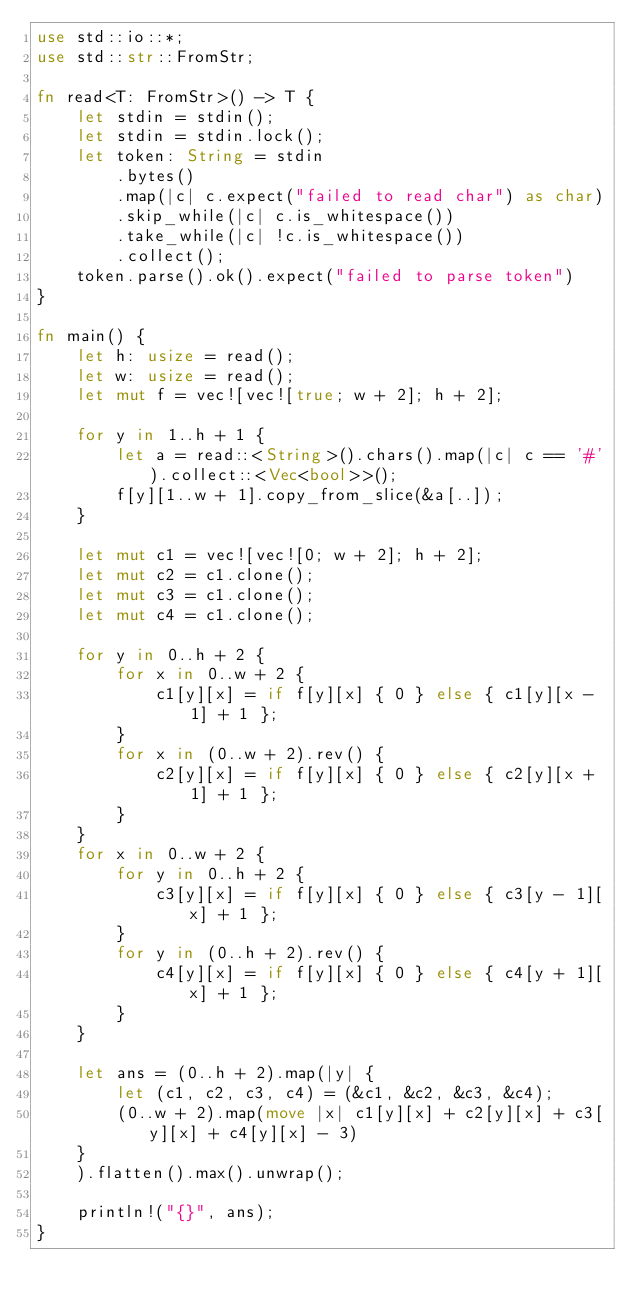Convert code to text. <code><loc_0><loc_0><loc_500><loc_500><_Rust_>use std::io::*;
use std::str::FromStr;

fn read<T: FromStr>() -> T {
    let stdin = stdin();
    let stdin = stdin.lock();
    let token: String = stdin
        .bytes()
        .map(|c| c.expect("failed to read char") as char)
        .skip_while(|c| c.is_whitespace())
        .take_while(|c| !c.is_whitespace())
        .collect();
    token.parse().ok().expect("failed to parse token")
}

fn main() {
    let h: usize = read();
    let w: usize = read();
    let mut f = vec![vec![true; w + 2]; h + 2];

    for y in 1..h + 1 {
        let a = read::<String>().chars().map(|c| c == '#').collect::<Vec<bool>>();
        f[y][1..w + 1].copy_from_slice(&a[..]);
    }

    let mut c1 = vec![vec![0; w + 2]; h + 2];
    let mut c2 = c1.clone();
    let mut c3 = c1.clone();
    let mut c4 = c1.clone();

    for y in 0..h + 2 {
        for x in 0..w + 2 {
            c1[y][x] = if f[y][x] { 0 } else { c1[y][x - 1] + 1 };
        }
        for x in (0..w + 2).rev() {
            c2[y][x] = if f[y][x] { 0 } else { c2[y][x + 1] + 1 };
        }
    }
    for x in 0..w + 2 {
        for y in 0..h + 2 {
            c3[y][x] = if f[y][x] { 0 } else { c3[y - 1][x] + 1 };
        }
        for y in (0..h + 2).rev() {
            c4[y][x] = if f[y][x] { 0 } else { c4[y + 1][x] + 1 };
        }
    }

    let ans = (0..h + 2).map(|y| {
        let (c1, c2, c3, c4) = (&c1, &c2, &c3, &c4);
        (0..w + 2).map(move |x| c1[y][x] + c2[y][x] + c3[y][x] + c4[y][x] - 3)
    }
    ).flatten().max().unwrap();

    println!("{}", ans);
}
</code> 